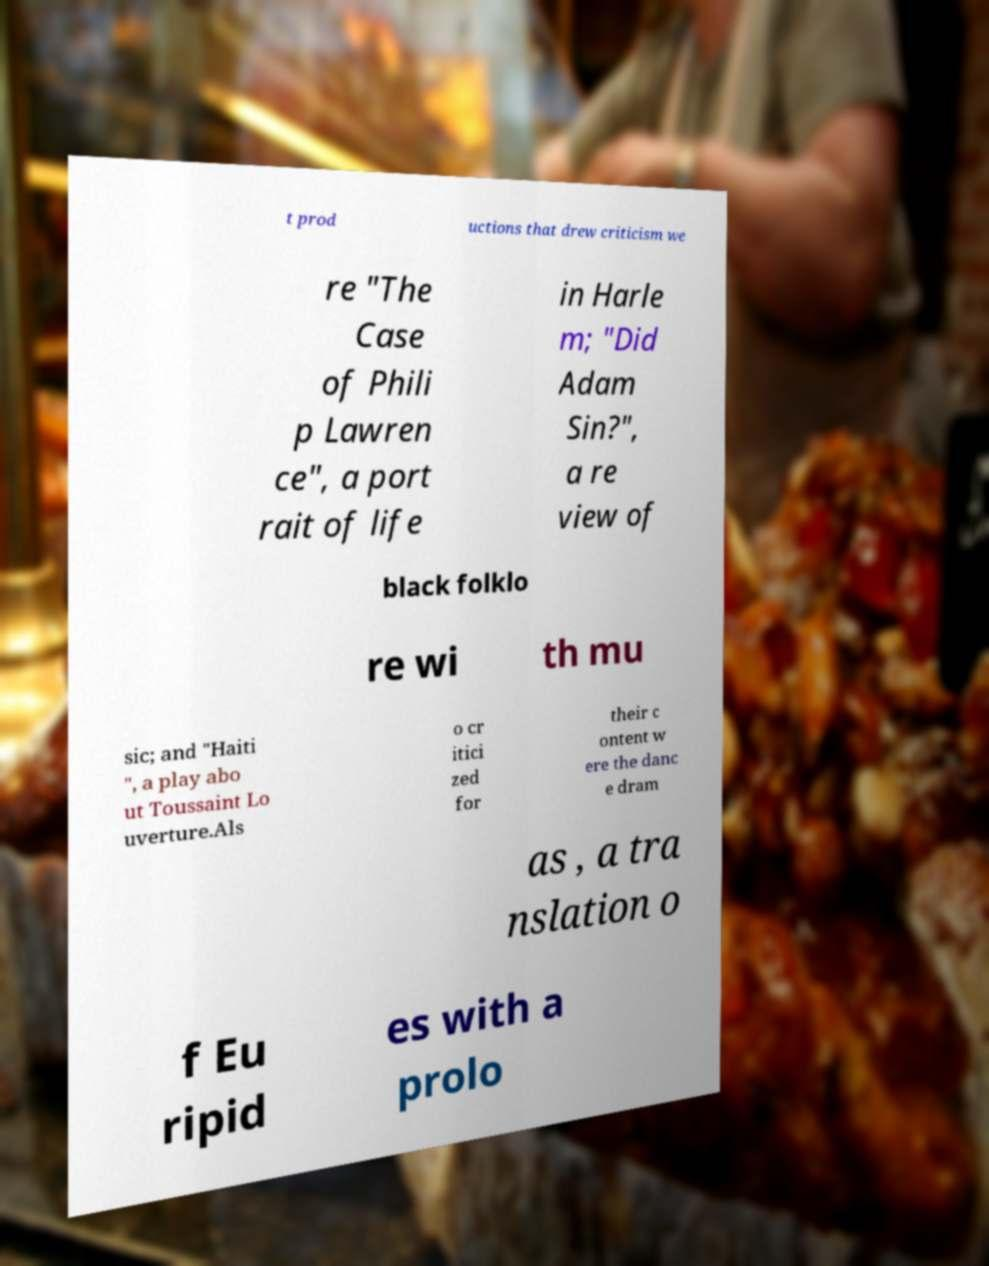Can you accurately transcribe the text from the provided image for me? t prod uctions that drew criticism we re "The Case of Phili p Lawren ce", a port rait of life in Harle m; "Did Adam Sin?", a re view of black folklo re wi th mu sic; and "Haiti ", a play abo ut Toussaint Lo uverture.Als o cr itici zed for their c ontent w ere the danc e dram as , a tra nslation o f Eu ripid es with a prolo 